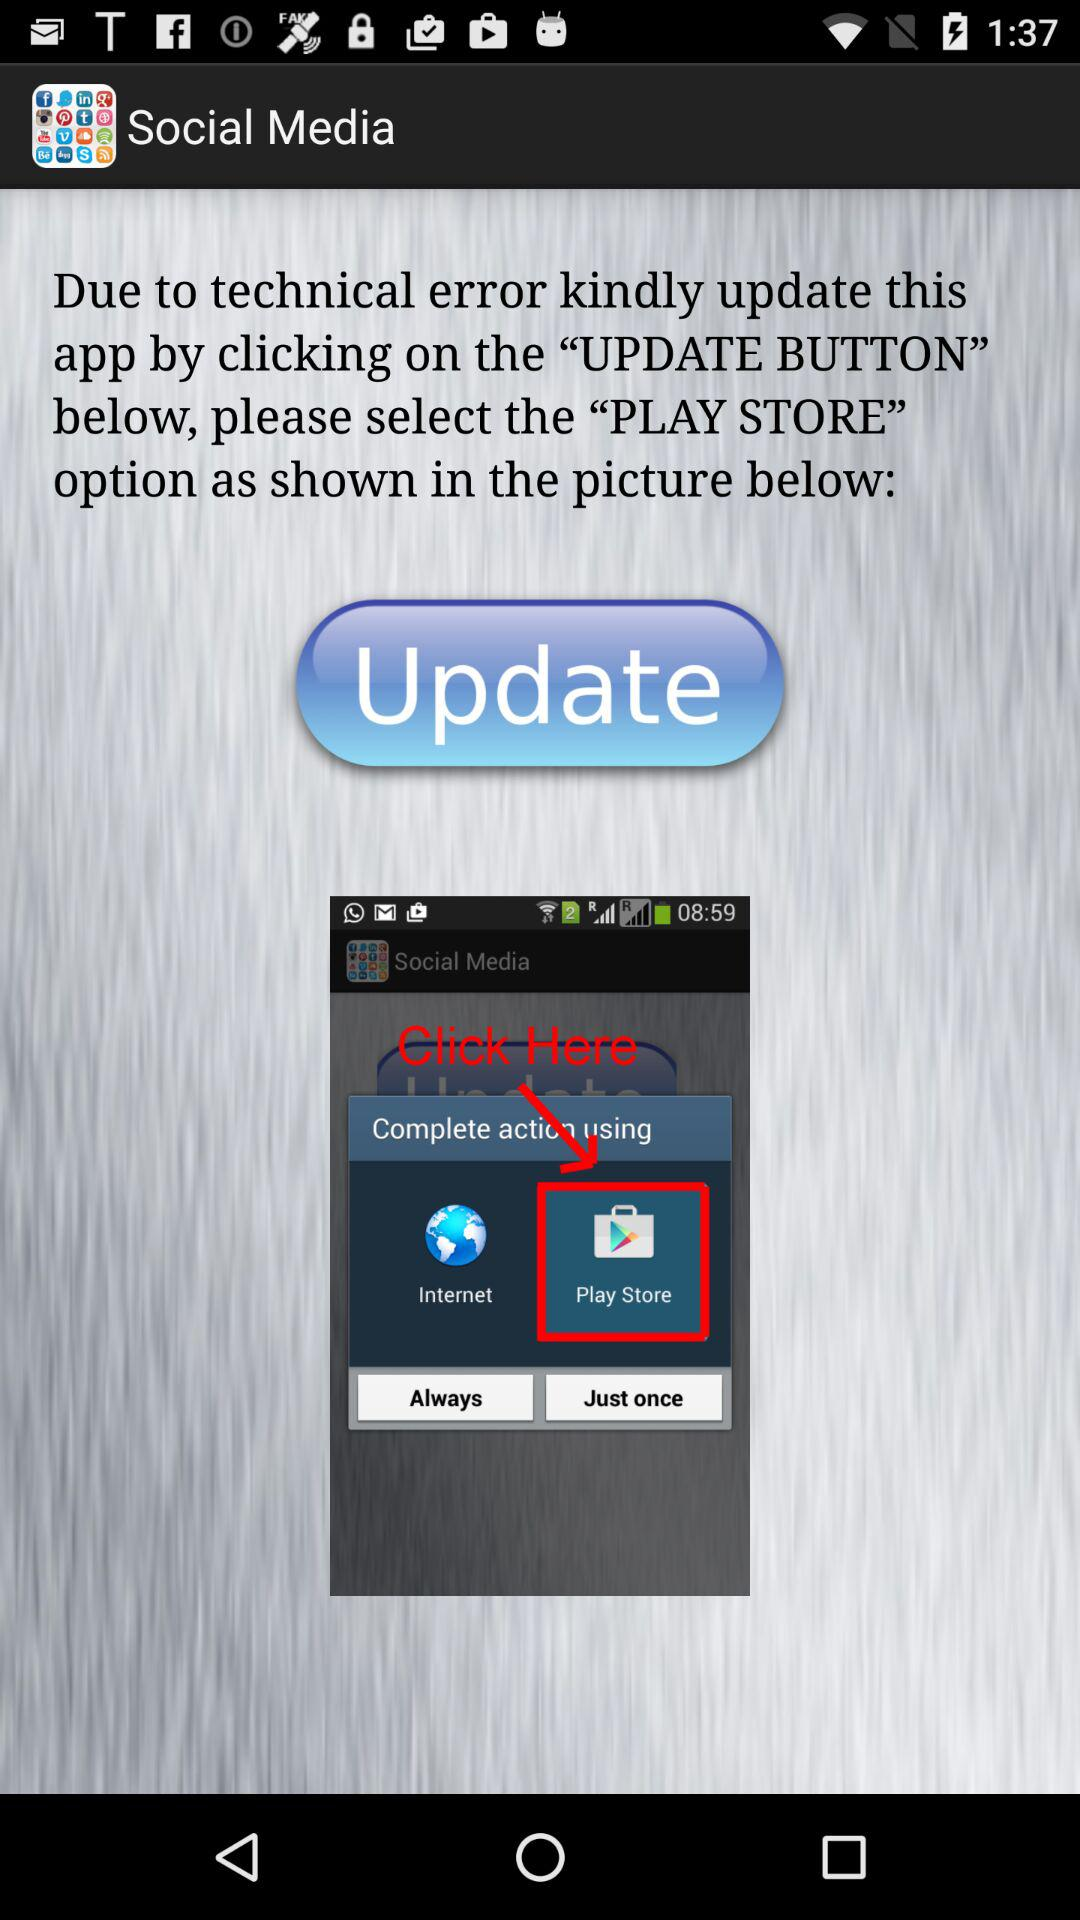What is the application name? The application name is "Social Media". 